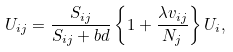Convert formula to latex. <formula><loc_0><loc_0><loc_500><loc_500>U _ { i j } = \frac { S _ { i j } } { S _ { i j } + b d } \left \{ 1 + \frac { \lambda v _ { i j } } { N _ { j } } \right \} U _ { i } ,</formula> 